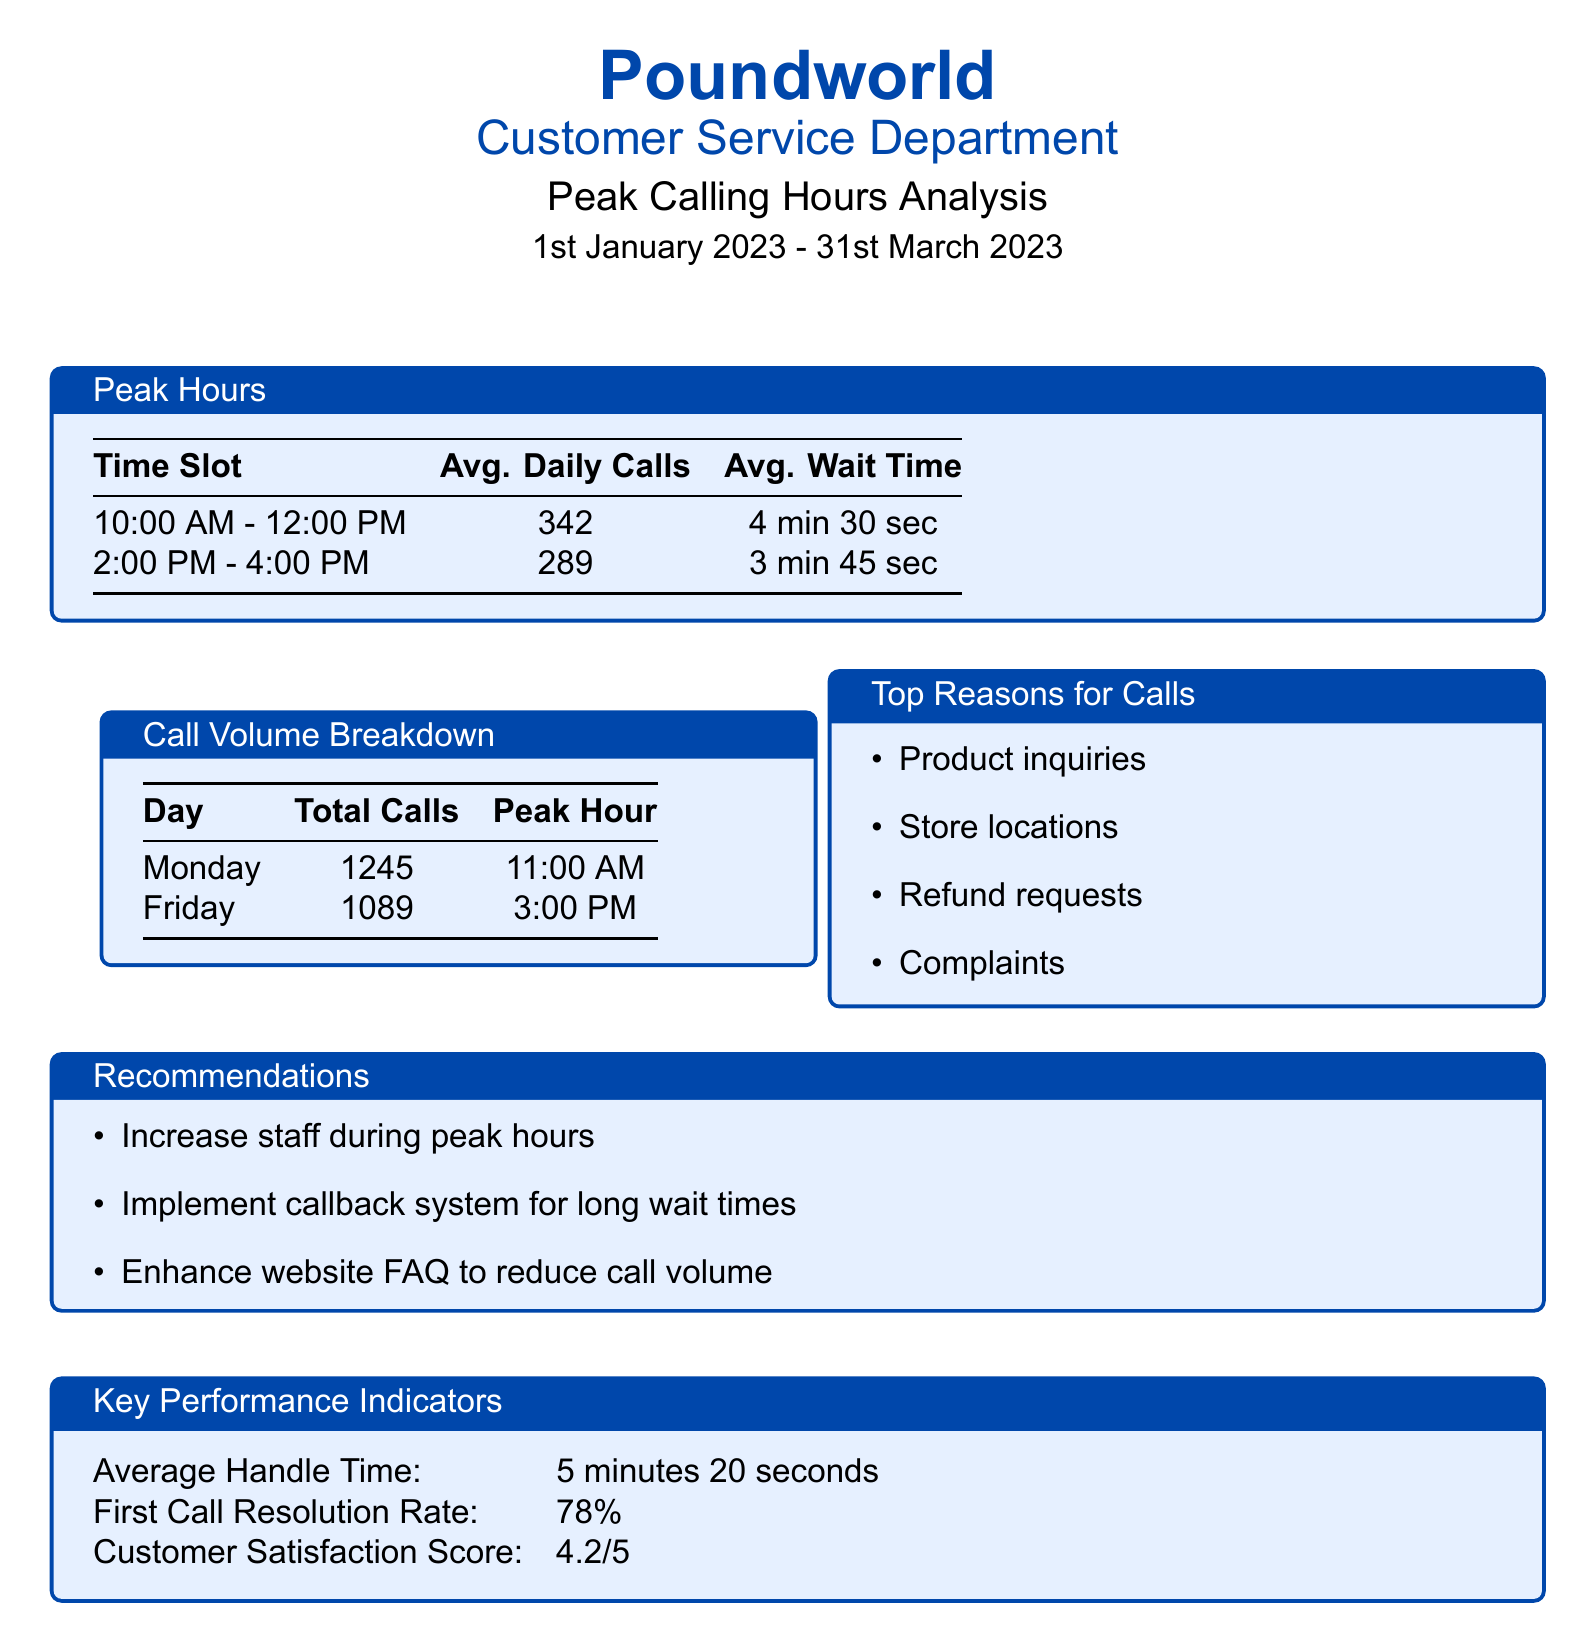What is the average number of daily calls from 10:00 AM to 12:00 PM? The average daily calls in this time slot are 342.
Answer: 342 What is the average wait time during the peak hours? The average wait time during peak hours is 4 minutes 30 seconds.
Answer: 4 min 30 sec Which day received the highest total calls? The day with the highest total calls is Monday, with 1245 calls.
Answer: Monday What is the peak hour on Fridays? The peak hour on Fridays is at 3:00 PM.
Answer: 3:00 PM What is the customer satisfaction score reported? The customer satisfaction score is 4.2 out of 5.
Answer: 4.2/5 What recommendation suggests improving call management? A recommendation is to implement a callback system for long wait times.
Answer: Implement callback system What are the top reasons for calls listed in the document? The top reasons for calls include product inquiries, store locations, refund requests, and complaints.
Answer: Product inquiries, store locations, refund requests, complaints What is the average handle time? The average handle time is 5 minutes 20 seconds.
Answer: 5 minutes 20 seconds What is the total volume of calls recorded for the analysis period? The document does not specify the total volume of calls, but lists daily averages and peak hours.
Answer: Not specified 